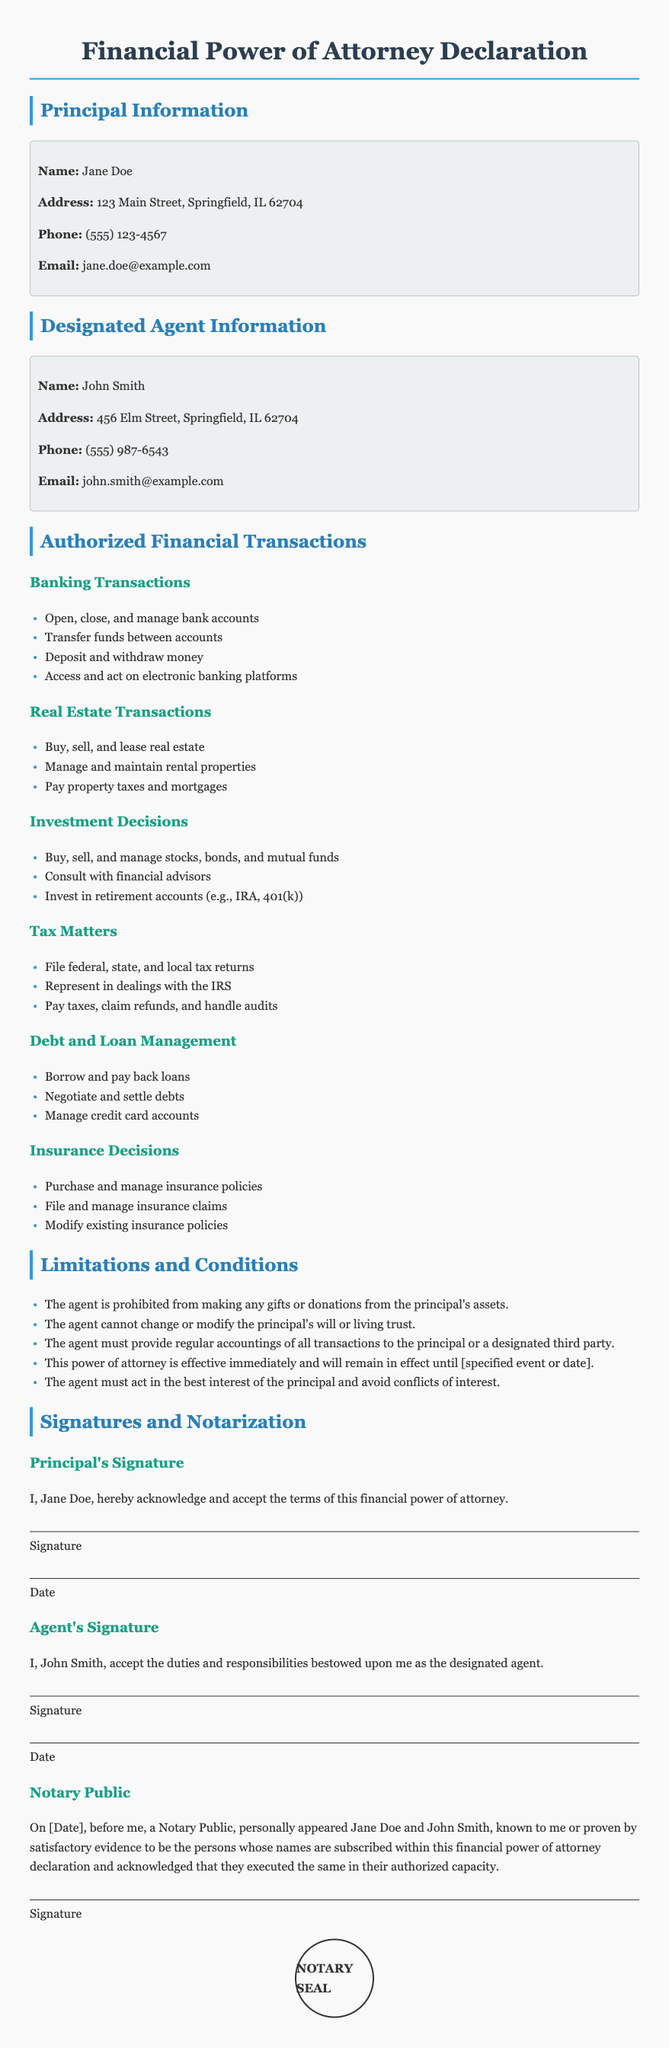What is the name of the principal? The principal is identified as Jane Doe in the document.
Answer: Jane Doe What is the designated agent’s address? The designated agent, John Smith, is listed with the address 456 Elm Street, Springfield, IL 62704.
Answer: 456 Elm Street, Springfield, IL 62704 What financial transaction is authorized regarding real estate? The document lists several transaction types, one of them being to buy, sell, and lease real estate.
Answer: Buy, sell, and lease real estate How many banking transactions are listed in the document? The document enumerates four specific banking transactions that the agent is authorized to perform.
Answer: Four What is one limitation placed on the agent? The document specifies that the agent is prohibited from making any gifts or donations from the principal's assets.
Answer: Gifts or donations What type of insurance decisions can the agent make? The agent is authorized to purchase and manage insurance policies according to the document.
Answer: Purchase and manage insurance policies Who needs to acknowledge the terms of the financial power of attorney? The principal, Jane Doe, must acknowledge and accept the terms.
Answer: Jane Doe What is the purpose of the notary public section? The notary public section is intended to validate the signatures and identities of the principal and agent.
Answer: Validate signatures and identities 